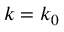Convert formula to latex. <formula><loc_0><loc_0><loc_500><loc_500>k = k _ { 0 }</formula> 